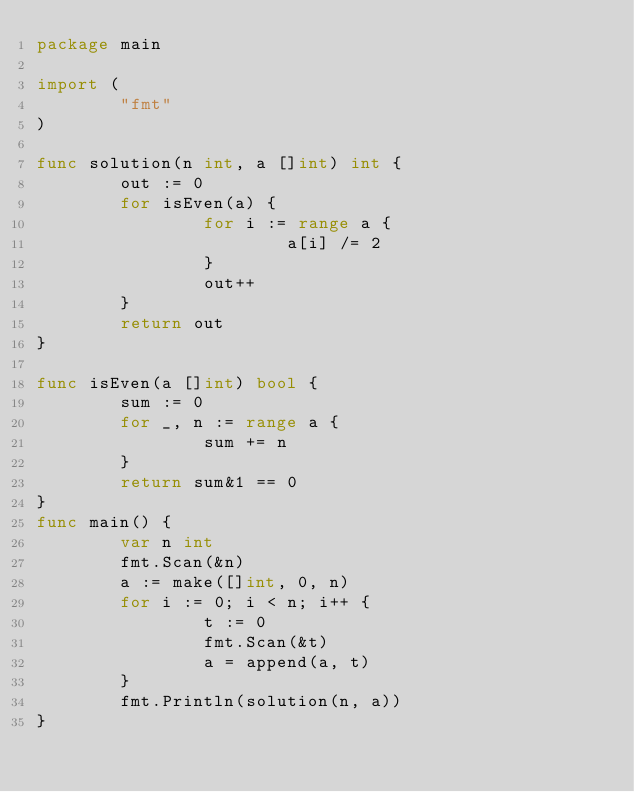<code> <loc_0><loc_0><loc_500><loc_500><_Go_>package main

import (
        "fmt"
)

func solution(n int, a []int) int {
        out := 0
        for isEven(a) {
                for i := range a {
                        a[i] /= 2
                }
                out++
        }
        return out
}

func isEven(a []int) bool {
        sum := 0
        for _, n := range a {
                sum += n
        }
        return sum&1 == 0
}
func main() {
        var n int
        fmt.Scan(&n)
        a := make([]int, 0, n)
        for i := 0; i < n; i++ {
                t := 0
                fmt.Scan(&t)
                a = append(a, t)
        }
        fmt.Println(solution(n, a))
}</code> 